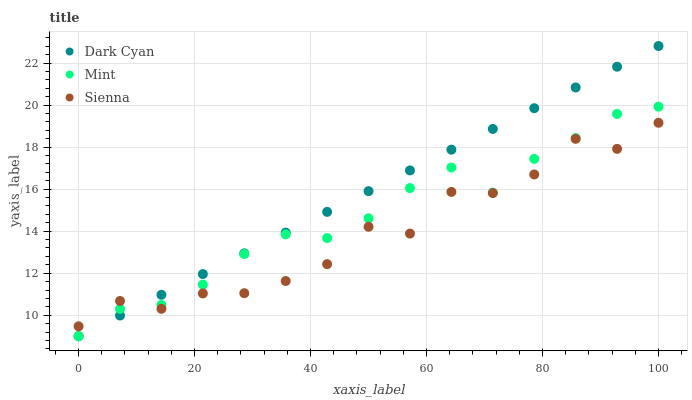Does Sienna have the minimum area under the curve?
Answer yes or no. Yes. Does Dark Cyan have the maximum area under the curve?
Answer yes or no. Yes. Does Mint have the minimum area under the curve?
Answer yes or no. No. Does Mint have the maximum area under the curve?
Answer yes or no. No. Is Dark Cyan the smoothest?
Answer yes or no. Yes. Is Sienna the roughest?
Answer yes or no. Yes. Is Mint the smoothest?
Answer yes or no. No. Is Mint the roughest?
Answer yes or no. No. Does Dark Cyan have the lowest value?
Answer yes or no. Yes. Does Sienna have the lowest value?
Answer yes or no. No. Does Dark Cyan have the highest value?
Answer yes or no. Yes. Does Mint have the highest value?
Answer yes or no. No. Does Dark Cyan intersect Mint?
Answer yes or no. Yes. Is Dark Cyan less than Mint?
Answer yes or no. No. Is Dark Cyan greater than Mint?
Answer yes or no. No. 